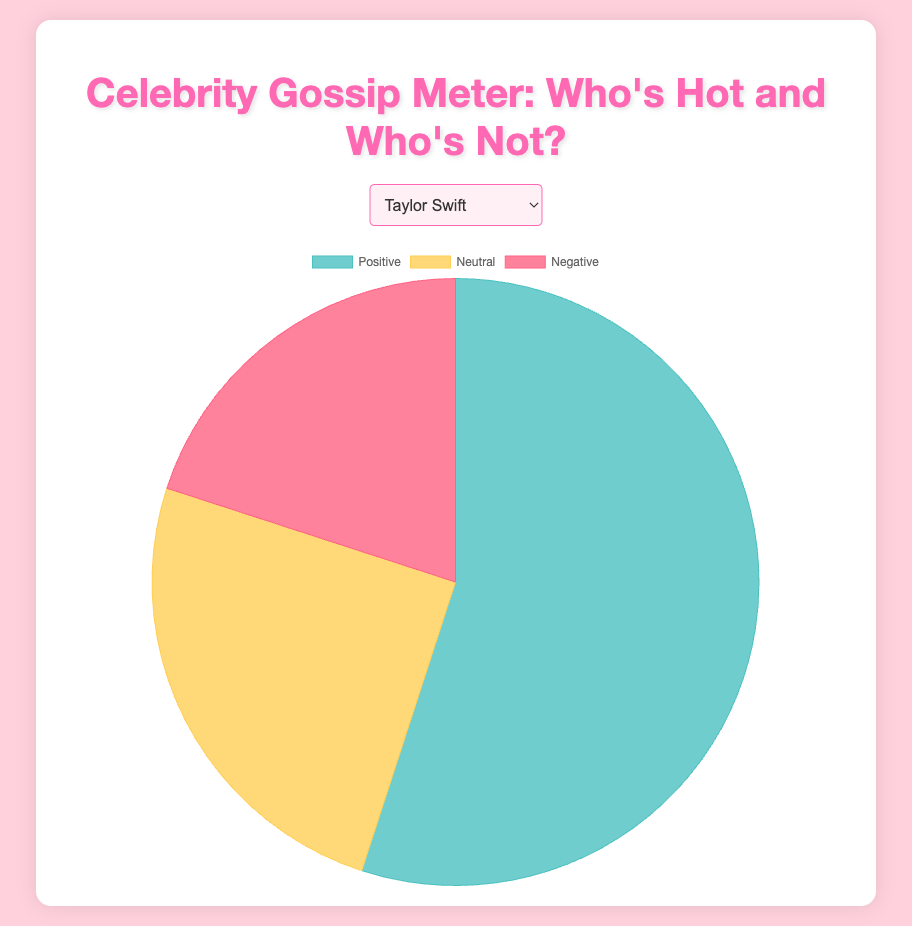Which celebrity has the highest percentage of negative opinion? By comparing the negative percentage of all celebrities, you will find that Kim Kardashian has the highest negative opinion percentage at 35%.
Answer: Kim Kardashian Who has a higher combined percentage of positive and neutral opinions, Taylor Swift or Tom Cruise? Add the positive and neutral percentages for both Taylor Swift and Tom Cruise. Taylor Swift has 55% (positive) + 25% (neutral) = 80%. Tom Cruise has 45% (positive) + 35% (neutral) = 80%. Both have the same combined percentage.
Answer: Both Which celebrity has the smallest percentage of neutral opinions? By comparing the neutral percentages of all celebrities, Jennifer Lawrence has the smallest neutral opinion percentage at 20%.
Answer: Jennifer Lawrence Compare the positive opinion percentages of Beyoncé and Ariana Grande. Who is more favored? Beyoncé has a positive opinion percentage of 65%, whereas Ariana Grande has 50%. Beyoncé is more favored.
Answer: Beyoncé What is the total percentage of negative opinions for Kanye West and Justin Bieber? Add the negative opinion percentages for Kanye West (30%) and Justin Bieber (30%). The total is 30% + 30% = 60%.
Answer: 60% Among Taylor Swift, Selena Gomez, and Chris Pratt, who has the highest positive opinion percentage, and by how much? Compare the positive opinion percentages: Taylor Swift (55%), Selena Gomez (60%), and Chris Pratt (55%). Selena Gomez has the highest at 60%, which is 5% higher than Taylor Swift and Chris Pratt.
Answer: Selena Gomez, by 5% What is the average neutral opinion percentage of Kim Kardashian, Tom Cruise, and Jennifer Lawrence? Add the neutral percentages: Kim Kardashian (30%), Tom Cruise (35%), Jennifer Lawrence (20%). The sum is 30% + 35% + 20% = 85%. Divide by 3: 85% / 3 = 28.33%
Answer: 28.33% Which celebrity has the closest percentage balance between positive and negative opinions, and what is that percentage? Compare the absolute differences between the positive and negative percentages for all celebrities. Kanye West has 30% positive and 30% negative, giving a balance of 0%.
Answer: Kanye West How does the neutral opinion percentage of Beyoncé compare to the negative opinion percentage of Selena Gomez? Beyoncé has a 20% neutral opinion and Selena Gomez has a 15% negative opinion. Beyoncé's neutral percentage is 5% higher.
Answer: 5% higher Who has more positive opinions, Taylor Swift or Ariana Grande? And by how much? Taylor Swift has a 55% positive opinion, while Ariana Grande has a 50% positive opinion. Taylor Swift has 5% more positive opinions.
Answer: Taylor Swift, by 5% 